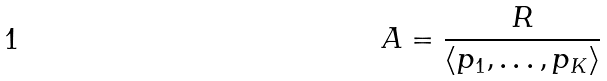<formula> <loc_0><loc_0><loc_500><loc_500>A = \frac { R } { \langle p _ { 1 } , \dots , p _ { K } \rangle }</formula> 